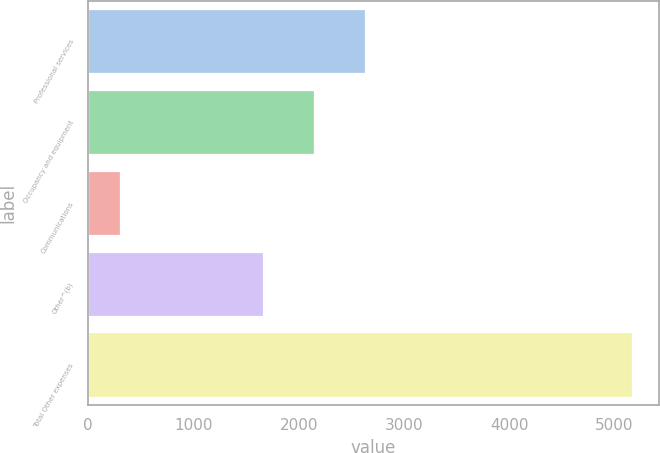Convert chart to OTSL. <chart><loc_0><loc_0><loc_500><loc_500><bar_chart><fcel>Professional services<fcel>Occupancy and equipment<fcel>Communications<fcel>Other^(b)<fcel>Total Other expenses<nl><fcel>2629<fcel>2143<fcel>302<fcel>1657<fcel>5162<nl></chart> 